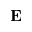Convert formula to latex. <formula><loc_0><loc_0><loc_500><loc_500>E</formula> 